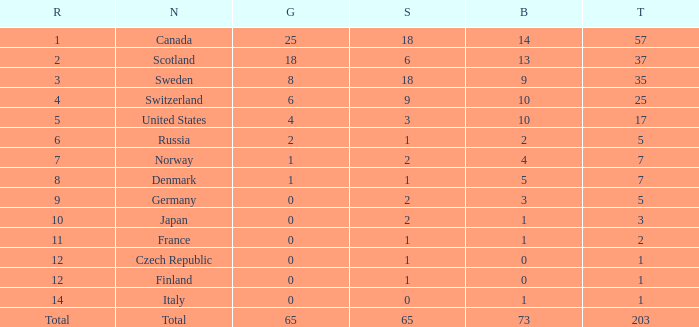What is the total number of medals when there are 18 gold medals? 37.0. 